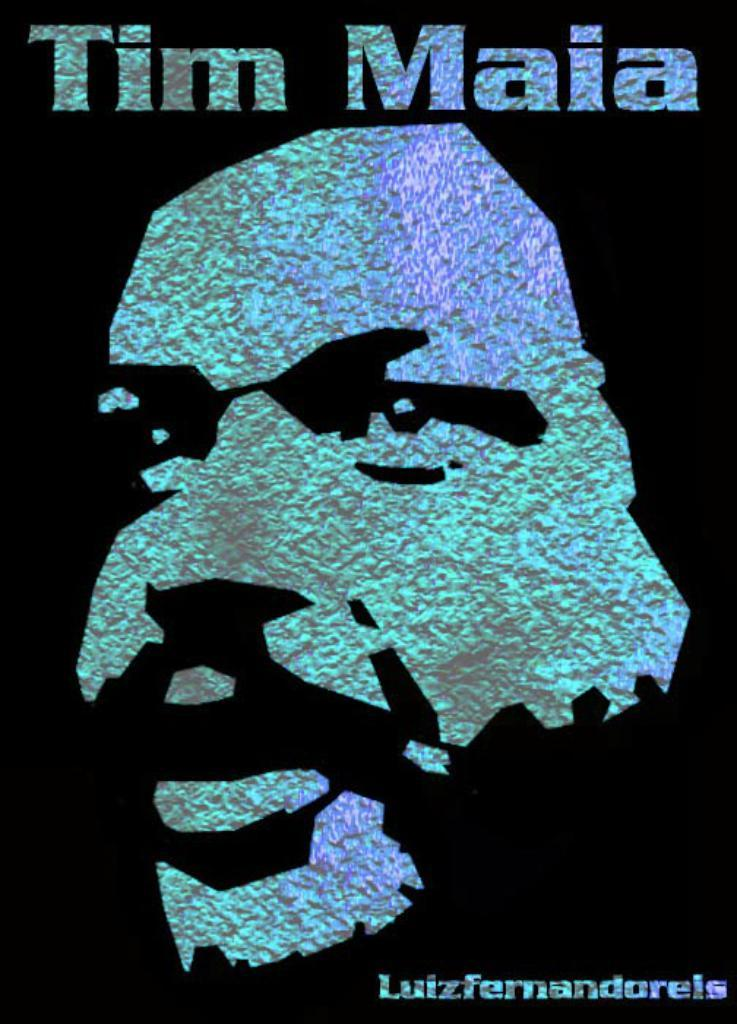Provide a one-sentence caption for the provided image. Poster showing a man's face and the name "Tim Maia". 